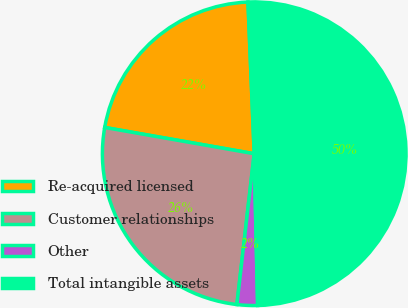<chart> <loc_0><loc_0><loc_500><loc_500><pie_chart><fcel>Re-acquired licensed<fcel>Customer relationships<fcel>Other<fcel>Total intangible assets<nl><fcel>21.58%<fcel>25.95%<fcel>2.18%<fcel>50.3%<nl></chart> 